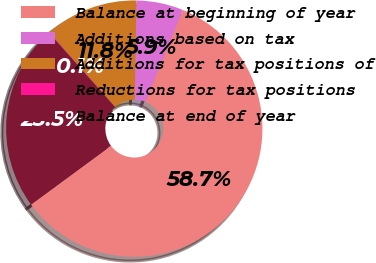<chart> <loc_0><loc_0><loc_500><loc_500><pie_chart><fcel>Balance at beginning of year<fcel>Additions based on tax<fcel>Additions for tax positions of<fcel>Reductions for tax positions<fcel>Balance at end of year<nl><fcel>58.73%<fcel>5.92%<fcel>11.78%<fcel>0.05%<fcel>23.52%<nl></chart> 